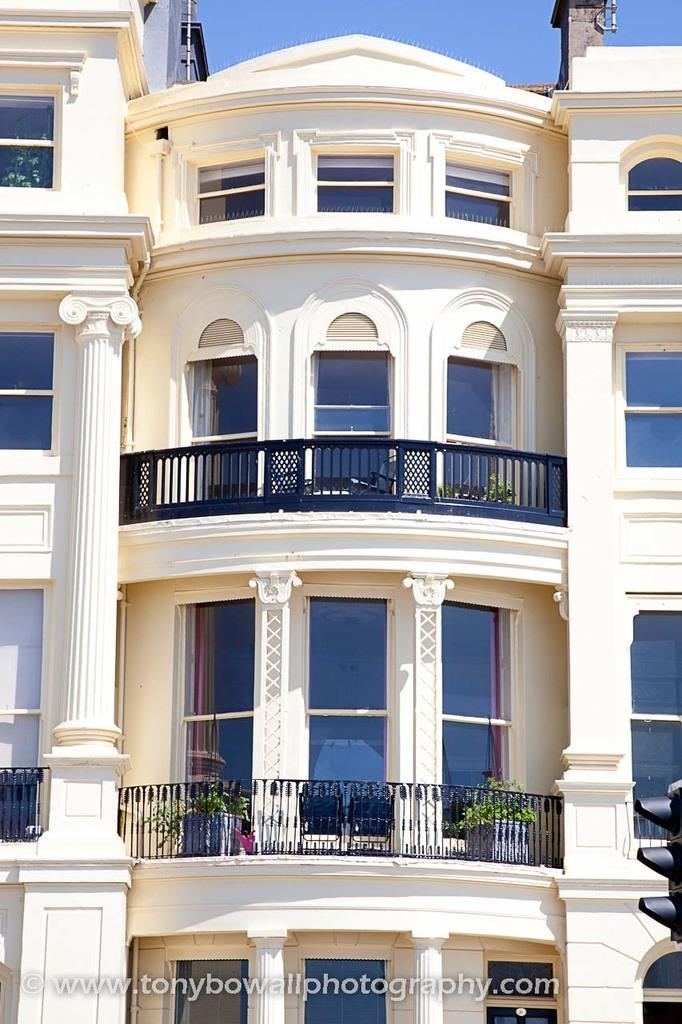What type of structure is present in the image? There is a building in the image. What feature of the building is mentioned in the facts? The building has windows. What other object can be seen in the image? There is a fence in the image. Are there any architectural elements visible in the image? Yes, there are pillars in the image. What else can be found in the image? There are plants and a traffic light in the image. What part of the natural environment is visible in the image? The sky is visible in the image. How many cows are present in the image? There are no cows present in the image. 